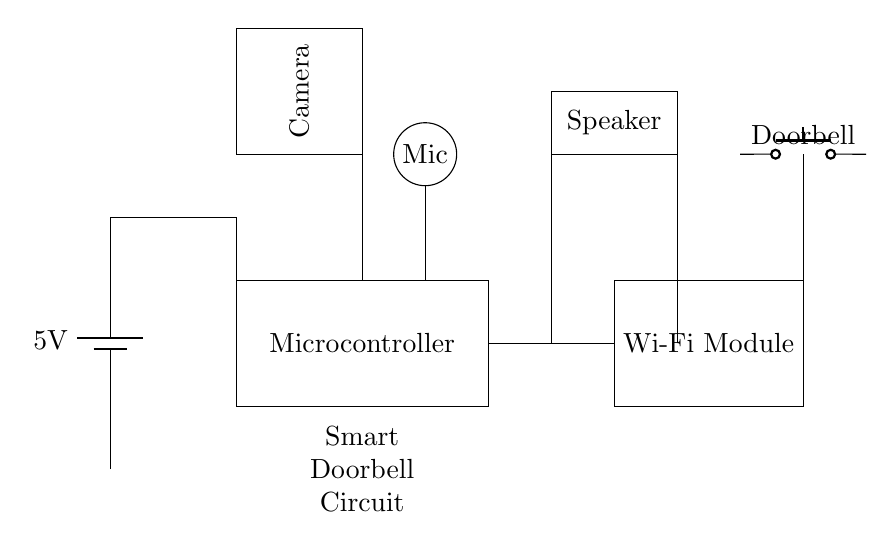What is the voltage of the power supply? The voltage of the power supply is indicated by the battery symbol and is labeled as 5V. This information is clearly shown near the top of the diagram.
Answer: 5 volts What are the main components in this circuit? The main components include a Microcontroller, Wi-Fi Module, Camera, Microphone, Speaker, and Doorbell button. These components are represented as distinct shapes in the circuit diagram.
Answer: Microcontroller, Wi-Fi Module, Camera, Microphone, Speaker, Doorbell How many audio input/output devices are present? The audio input/output devices consist of one microphone (input) and one speaker (output). The microphone is depicted as a circle, while the speaker is represented as a rectangle.
Answer: Two What is the purpose of the Wi-Fi module in the circuit? The Wi-Fi module enables the smart doorbell to connect to a wireless network, allowing for video streaming and two-way audio communication. Its role is essential for smartphone connectivity features.
Answer: Network connectivity Which component is activated when the doorbell button is pressed? When the doorbell button is pressed, it activates the Microcontroller as it detects the signal from the button. The Microcontroller is typically responsible for managing inputs and outputs.
Answer: Microcontroller How many connections are made from the Microcontroller? There are three visible connections made from the Microcontroller: one to the Wi-Fi module, one to the Camera, and one to the Microphone, indicating that it processes inputs and outputs to these devices.
Answer: Three 